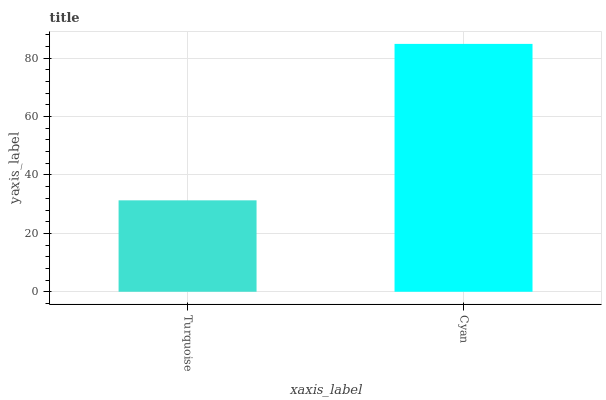Is Cyan the minimum?
Answer yes or no. No. Is Cyan greater than Turquoise?
Answer yes or no. Yes. Is Turquoise less than Cyan?
Answer yes or no. Yes. Is Turquoise greater than Cyan?
Answer yes or no. No. Is Cyan less than Turquoise?
Answer yes or no. No. Is Cyan the high median?
Answer yes or no. Yes. Is Turquoise the low median?
Answer yes or no. Yes. Is Turquoise the high median?
Answer yes or no. No. Is Cyan the low median?
Answer yes or no. No. 